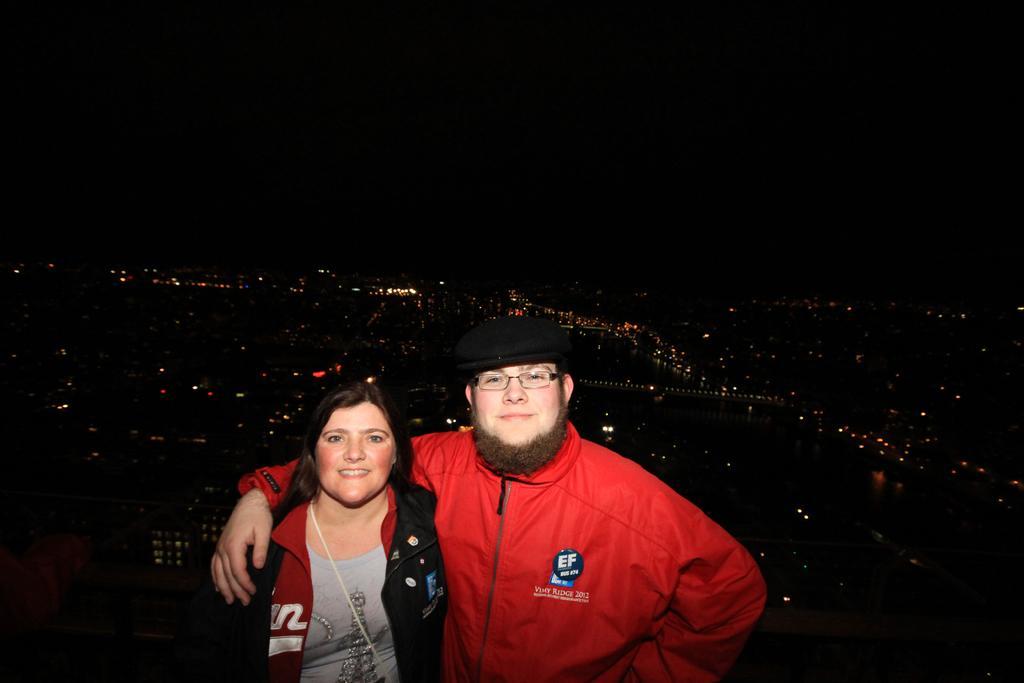Describe this image in one or two sentences. In this image we can see a man and a woman. Man is wearing specs and cap. In the background it is dark. And we can see lights. 